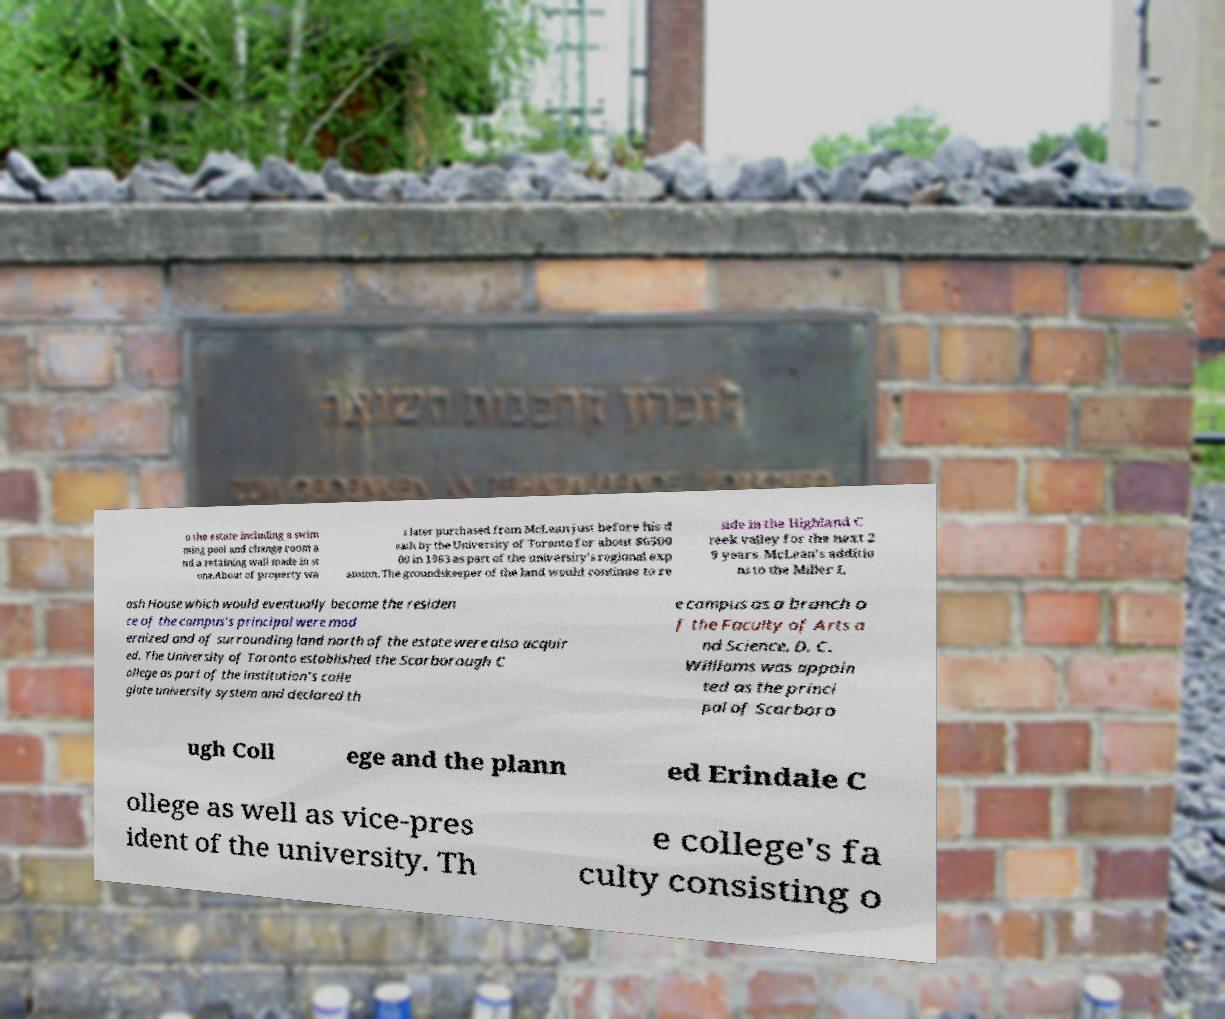There's text embedded in this image that I need extracted. Can you transcribe it verbatim? o the estate including a swim ming pool and change room a nd a retaining wall made in st one.About of property wa s later purchased from McLean just before his d eath by the University of Toronto for about $6500 00 in 1963 as part of the university's regional exp ansion. The groundskeeper of the land would continue to re side in the Highland C reek valley for the next 2 9 years. McLean's additio ns to the Miller L ash House which would eventually become the residen ce of the campus's principal were mod ernized and of surrounding land north of the estate were also acquir ed. The University of Toronto established the Scarborough C ollege as part of the institution's colle giate university system and declared th e campus as a branch o f the Faculty of Arts a nd Science. D. C. Williams was appoin ted as the princi pal of Scarboro ugh Coll ege and the plann ed Erindale C ollege as well as vice-pres ident of the university. Th e college's fa culty consisting o 